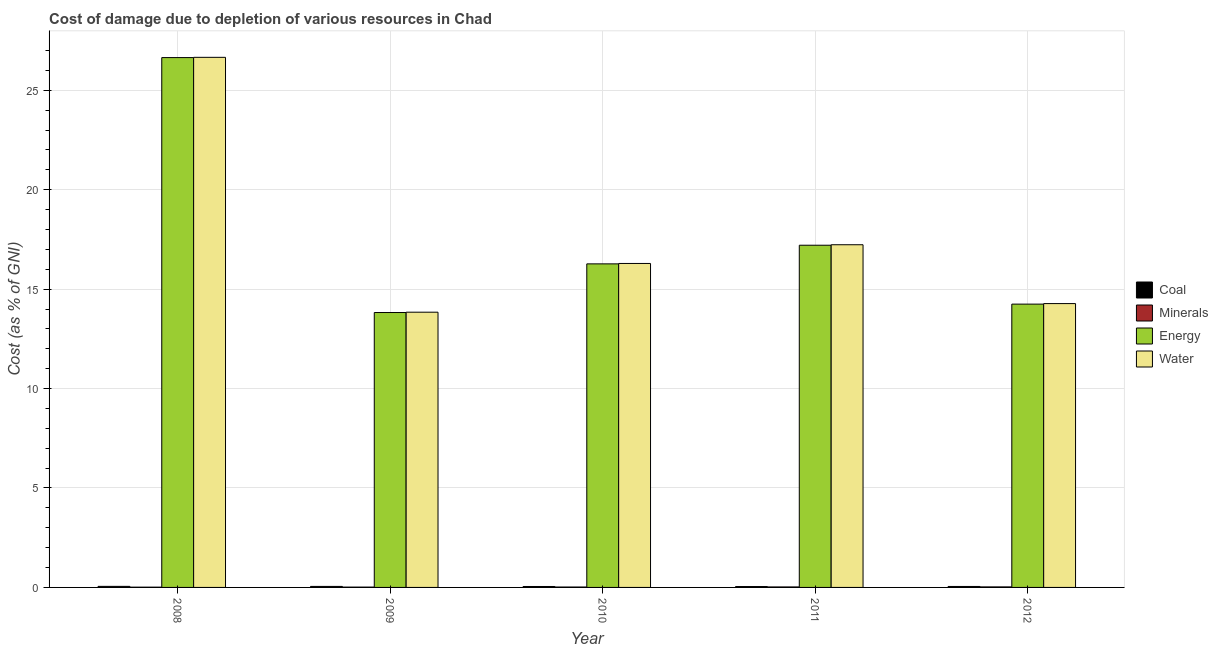How many groups of bars are there?
Keep it short and to the point. 5. Are the number of bars per tick equal to the number of legend labels?
Make the answer very short. Yes. Are the number of bars on each tick of the X-axis equal?
Your answer should be compact. Yes. What is the cost of damage due to depletion of minerals in 2008?
Provide a succinct answer. 0.01. Across all years, what is the maximum cost of damage due to depletion of minerals?
Your answer should be compact. 0.03. Across all years, what is the minimum cost of damage due to depletion of coal?
Your answer should be compact. 0.04. In which year was the cost of damage due to depletion of energy maximum?
Ensure brevity in your answer.  2008. In which year was the cost of damage due to depletion of water minimum?
Your answer should be very brief. 2009. What is the total cost of damage due to depletion of energy in the graph?
Your answer should be very brief. 88.19. What is the difference between the cost of damage due to depletion of minerals in 2008 and that in 2010?
Your answer should be very brief. -0.01. What is the difference between the cost of damage due to depletion of minerals in 2010 and the cost of damage due to depletion of coal in 2011?
Ensure brevity in your answer.  -0. What is the average cost of damage due to depletion of water per year?
Offer a terse response. 17.66. In the year 2008, what is the difference between the cost of damage due to depletion of coal and cost of damage due to depletion of energy?
Your response must be concise. 0. In how many years, is the cost of damage due to depletion of minerals greater than 15 %?
Offer a very short reply. 0. What is the ratio of the cost of damage due to depletion of coal in 2008 to that in 2009?
Provide a succinct answer. 1.04. Is the cost of damage due to depletion of coal in 2009 less than that in 2011?
Ensure brevity in your answer.  No. What is the difference between the highest and the second highest cost of damage due to depletion of minerals?
Your answer should be compact. 0. What is the difference between the highest and the lowest cost of damage due to depletion of minerals?
Provide a succinct answer. 0.01. What does the 3rd bar from the left in 2009 represents?
Ensure brevity in your answer.  Energy. What does the 3rd bar from the right in 2010 represents?
Provide a succinct answer. Minerals. How many bars are there?
Provide a succinct answer. 20. How many years are there in the graph?
Provide a succinct answer. 5. What is the difference between two consecutive major ticks on the Y-axis?
Your answer should be compact. 5. Does the graph contain grids?
Provide a short and direct response. Yes. What is the title of the graph?
Make the answer very short. Cost of damage due to depletion of various resources in Chad . What is the label or title of the X-axis?
Make the answer very short. Year. What is the label or title of the Y-axis?
Make the answer very short. Cost (as % of GNI). What is the Cost (as % of GNI) in Coal in 2008?
Provide a succinct answer. 0.05. What is the Cost (as % of GNI) in Minerals in 2008?
Ensure brevity in your answer.  0.01. What is the Cost (as % of GNI) of Energy in 2008?
Ensure brevity in your answer.  26.64. What is the Cost (as % of GNI) of Water in 2008?
Provide a short and direct response. 26.66. What is the Cost (as % of GNI) in Coal in 2009?
Provide a succinct answer. 0.05. What is the Cost (as % of GNI) of Minerals in 2009?
Provide a short and direct response. 0.02. What is the Cost (as % of GNI) of Energy in 2009?
Offer a very short reply. 13.82. What is the Cost (as % of GNI) of Water in 2009?
Your answer should be compact. 13.84. What is the Cost (as % of GNI) in Coal in 2010?
Ensure brevity in your answer.  0.05. What is the Cost (as % of GNI) of Minerals in 2010?
Your answer should be very brief. 0.02. What is the Cost (as % of GNI) in Energy in 2010?
Give a very brief answer. 16.27. What is the Cost (as % of GNI) in Water in 2010?
Give a very brief answer. 16.29. What is the Cost (as % of GNI) of Coal in 2011?
Make the answer very short. 0.04. What is the Cost (as % of GNI) of Minerals in 2011?
Keep it short and to the point. 0.02. What is the Cost (as % of GNI) of Energy in 2011?
Ensure brevity in your answer.  17.21. What is the Cost (as % of GNI) of Water in 2011?
Give a very brief answer. 17.23. What is the Cost (as % of GNI) of Coal in 2012?
Offer a very short reply. 0.05. What is the Cost (as % of GNI) of Minerals in 2012?
Offer a terse response. 0.03. What is the Cost (as % of GNI) in Energy in 2012?
Ensure brevity in your answer.  14.25. What is the Cost (as % of GNI) in Water in 2012?
Provide a short and direct response. 14.27. Across all years, what is the maximum Cost (as % of GNI) in Coal?
Your answer should be compact. 0.05. Across all years, what is the maximum Cost (as % of GNI) in Minerals?
Your answer should be very brief. 0.03. Across all years, what is the maximum Cost (as % of GNI) of Energy?
Your response must be concise. 26.64. Across all years, what is the maximum Cost (as % of GNI) of Water?
Make the answer very short. 26.66. Across all years, what is the minimum Cost (as % of GNI) in Coal?
Provide a short and direct response. 0.04. Across all years, what is the minimum Cost (as % of GNI) of Minerals?
Provide a succinct answer. 0.01. Across all years, what is the minimum Cost (as % of GNI) in Energy?
Make the answer very short. 13.82. Across all years, what is the minimum Cost (as % of GNI) in Water?
Your answer should be very brief. 13.84. What is the total Cost (as % of GNI) in Coal in the graph?
Offer a terse response. 0.24. What is the total Cost (as % of GNI) in Minerals in the graph?
Give a very brief answer. 0.1. What is the total Cost (as % of GNI) of Energy in the graph?
Provide a short and direct response. 88.19. What is the total Cost (as % of GNI) in Water in the graph?
Your answer should be very brief. 88.29. What is the difference between the Cost (as % of GNI) in Coal in 2008 and that in 2009?
Provide a short and direct response. 0. What is the difference between the Cost (as % of GNI) in Minerals in 2008 and that in 2009?
Offer a very short reply. -0. What is the difference between the Cost (as % of GNI) of Energy in 2008 and that in 2009?
Your response must be concise. 12.82. What is the difference between the Cost (as % of GNI) of Water in 2008 and that in 2009?
Ensure brevity in your answer.  12.82. What is the difference between the Cost (as % of GNI) in Coal in 2008 and that in 2010?
Provide a short and direct response. 0.01. What is the difference between the Cost (as % of GNI) of Minerals in 2008 and that in 2010?
Make the answer very short. -0.01. What is the difference between the Cost (as % of GNI) in Energy in 2008 and that in 2010?
Your answer should be compact. 10.37. What is the difference between the Cost (as % of GNI) in Water in 2008 and that in 2010?
Offer a terse response. 10.37. What is the difference between the Cost (as % of GNI) of Coal in 2008 and that in 2011?
Your answer should be compact. 0.01. What is the difference between the Cost (as % of GNI) in Minerals in 2008 and that in 2011?
Your answer should be compact. -0.01. What is the difference between the Cost (as % of GNI) in Energy in 2008 and that in 2011?
Ensure brevity in your answer.  9.44. What is the difference between the Cost (as % of GNI) in Water in 2008 and that in 2011?
Offer a very short reply. 9.42. What is the difference between the Cost (as % of GNI) in Coal in 2008 and that in 2012?
Provide a succinct answer. 0. What is the difference between the Cost (as % of GNI) in Minerals in 2008 and that in 2012?
Your answer should be very brief. -0.01. What is the difference between the Cost (as % of GNI) of Energy in 2008 and that in 2012?
Give a very brief answer. 12.4. What is the difference between the Cost (as % of GNI) of Water in 2008 and that in 2012?
Your response must be concise. 12.38. What is the difference between the Cost (as % of GNI) in Coal in 2009 and that in 2010?
Provide a short and direct response. 0. What is the difference between the Cost (as % of GNI) of Minerals in 2009 and that in 2010?
Make the answer very short. -0. What is the difference between the Cost (as % of GNI) in Energy in 2009 and that in 2010?
Make the answer very short. -2.45. What is the difference between the Cost (as % of GNI) in Water in 2009 and that in 2010?
Ensure brevity in your answer.  -2.45. What is the difference between the Cost (as % of GNI) of Coal in 2009 and that in 2011?
Your response must be concise. 0.01. What is the difference between the Cost (as % of GNI) of Minerals in 2009 and that in 2011?
Provide a short and direct response. -0.01. What is the difference between the Cost (as % of GNI) of Energy in 2009 and that in 2011?
Keep it short and to the point. -3.38. What is the difference between the Cost (as % of GNI) of Water in 2009 and that in 2011?
Your answer should be very brief. -3.39. What is the difference between the Cost (as % of GNI) in Coal in 2009 and that in 2012?
Offer a terse response. 0. What is the difference between the Cost (as % of GNI) of Minerals in 2009 and that in 2012?
Give a very brief answer. -0.01. What is the difference between the Cost (as % of GNI) in Energy in 2009 and that in 2012?
Make the answer very short. -0.42. What is the difference between the Cost (as % of GNI) in Water in 2009 and that in 2012?
Give a very brief answer. -0.43. What is the difference between the Cost (as % of GNI) in Coal in 2010 and that in 2011?
Make the answer very short. 0. What is the difference between the Cost (as % of GNI) of Minerals in 2010 and that in 2011?
Your answer should be compact. -0. What is the difference between the Cost (as % of GNI) in Energy in 2010 and that in 2011?
Provide a succinct answer. -0.94. What is the difference between the Cost (as % of GNI) in Water in 2010 and that in 2011?
Provide a succinct answer. -0.94. What is the difference between the Cost (as % of GNI) of Coal in 2010 and that in 2012?
Offer a terse response. -0. What is the difference between the Cost (as % of GNI) in Minerals in 2010 and that in 2012?
Give a very brief answer. -0.01. What is the difference between the Cost (as % of GNI) of Energy in 2010 and that in 2012?
Your response must be concise. 2.02. What is the difference between the Cost (as % of GNI) in Water in 2010 and that in 2012?
Offer a terse response. 2.02. What is the difference between the Cost (as % of GNI) in Coal in 2011 and that in 2012?
Offer a terse response. -0. What is the difference between the Cost (as % of GNI) of Minerals in 2011 and that in 2012?
Give a very brief answer. -0. What is the difference between the Cost (as % of GNI) of Energy in 2011 and that in 2012?
Make the answer very short. 2.96. What is the difference between the Cost (as % of GNI) in Water in 2011 and that in 2012?
Provide a short and direct response. 2.96. What is the difference between the Cost (as % of GNI) in Coal in 2008 and the Cost (as % of GNI) in Minerals in 2009?
Offer a very short reply. 0.04. What is the difference between the Cost (as % of GNI) of Coal in 2008 and the Cost (as % of GNI) of Energy in 2009?
Keep it short and to the point. -13.77. What is the difference between the Cost (as % of GNI) in Coal in 2008 and the Cost (as % of GNI) in Water in 2009?
Your answer should be very brief. -13.79. What is the difference between the Cost (as % of GNI) of Minerals in 2008 and the Cost (as % of GNI) of Energy in 2009?
Give a very brief answer. -13.81. What is the difference between the Cost (as % of GNI) in Minerals in 2008 and the Cost (as % of GNI) in Water in 2009?
Offer a terse response. -13.83. What is the difference between the Cost (as % of GNI) of Energy in 2008 and the Cost (as % of GNI) of Water in 2009?
Your response must be concise. 12.8. What is the difference between the Cost (as % of GNI) in Coal in 2008 and the Cost (as % of GNI) in Minerals in 2010?
Provide a succinct answer. 0.03. What is the difference between the Cost (as % of GNI) in Coal in 2008 and the Cost (as % of GNI) in Energy in 2010?
Your response must be concise. -16.22. What is the difference between the Cost (as % of GNI) of Coal in 2008 and the Cost (as % of GNI) of Water in 2010?
Make the answer very short. -16.24. What is the difference between the Cost (as % of GNI) in Minerals in 2008 and the Cost (as % of GNI) in Energy in 2010?
Offer a very short reply. -16.26. What is the difference between the Cost (as % of GNI) of Minerals in 2008 and the Cost (as % of GNI) of Water in 2010?
Provide a succinct answer. -16.28. What is the difference between the Cost (as % of GNI) in Energy in 2008 and the Cost (as % of GNI) in Water in 2010?
Provide a succinct answer. 10.35. What is the difference between the Cost (as % of GNI) of Coal in 2008 and the Cost (as % of GNI) of Minerals in 2011?
Ensure brevity in your answer.  0.03. What is the difference between the Cost (as % of GNI) of Coal in 2008 and the Cost (as % of GNI) of Energy in 2011?
Your answer should be compact. -17.15. What is the difference between the Cost (as % of GNI) in Coal in 2008 and the Cost (as % of GNI) in Water in 2011?
Provide a short and direct response. -17.18. What is the difference between the Cost (as % of GNI) in Minerals in 2008 and the Cost (as % of GNI) in Energy in 2011?
Your response must be concise. -17.19. What is the difference between the Cost (as % of GNI) in Minerals in 2008 and the Cost (as % of GNI) in Water in 2011?
Keep it short and to the point. -17.22. What is the difference between the Cost (as % of GNI) of Energy in 2008 and the Cost (as % of GNI) of Water in 2011?
Make the answer very short. 9.41. What is the difference between the Cost (as % of GNI) of Coal in 2008 and the Cost (as % of GNI) of Minerals in 2012?
Offer a terse response. 0.03. What is the difference between the Cost (as % of GNI) of Coal in 2008 and the Cost (as % of GNI) of Energy in 2012?
Give a very brief answer. -14.19. What is the difference between the Cost (as % of GNI) in Coal in 2008 and the Cost (as % of GNI) in Water in 2012?
Offer a terse response. -14.22. What is the difference between the Cost (as % of GNI) in Minerals in 2008 and the Cost (as % of GNI) in Energy in 2012?
Provide a short and direct response. -14.23. What is the difference between the Cost (as % of GNI) in Minerals in 2008 and the Cost (as % of GNI) in Water in 2012?
Provide a succinct answer. -14.26. What is the difference between the Cost (as % of GNI) in Energy in 2008 and the Cost (as % of GNI) in Water in 2012?
Your response must be concise. 12.37. What is the difference between the Cost (as % of GNI) in Coal in 2009 and the Cost (as % of GNI) in Minerals in 2010?
Your answer should be very brief. 0.03. What is the difference between the Cost (as % of GNI) in Coal in 2009 and the Cost (as % of GNI) in Energy in 2010?
Ensure brevity in your answer.  -16.22. What is the difference between the Cost (as % of GNI) of Coal in 2009 and the Cost (as % of GNI) of Water in 2010?
Ensure brevity in your answer.  -16.24. What is the difference between the Cost (as % of GNI) of Minerals in 2009 and the Cost (as % of GNI) of Energy in 2010?
Give a very brief answer. -16.25. What is the difference between the Cost (as % of GNI) in Minerals in 2009 and the Cost (as % of GNI) in Water in 2010?
Provide a short and direct response. -16.27. What is the difference between the Cost (as % of GNI) of Energy in 2009 and the Cost (as % of GNI) of Water in 2010?
Provide a short and direct response. -2.47. What is the difference between the Cost (as % of GNI) of Coal in 2009 and the Cost (as % of GNI) of Minerals in 2011?
Make the answer very short. 0.03. What is the difference between the Cost (as % of GNI) of Coal in 2009 and the Cost (as % of GNI) of Energy in 2011?
Your answer should be compact. -17.16. What is the difference between the Cost (as % of GNI) in Coal in 2009 and the Cost (as % of GNI) in Water in 2011?
Offer a very short reply. -17.18. What is the difference between the Cost (as % of GNI) of Minerals in 2009 and the Cost (as % of GNI) of Energy in 2011?
Provide a succinct answer. -17.19. What is the difference between the Cost (as % of GNI) of Minerals in 2009 and the Cost (as % of GNI) of Water in 2011?
Your answer should be very brief. -17.22. What is the difference between the Cost (as % of GNI) of Energy in 2009 and the Cost (as % of GNI) of Water in 2011?
Make the answer very short. -3.41. What is the difference between the Cost (as % of GNI) of Coal in 2009 and the Cost (as % of GNI) of Minerals in 2012?
Your answer should be compact. 0.02. What is the difference between the Cost (as % of GNI) of Coal in 2009 and the Cost (as % of GNI) of Energy in 2012?
Keep it short and to the point. -14.2. What is the difference between the Cost (as % of GNI) of Coal in 2009 and the Cost (as % of GNI) of Water in 2012?
Give a very brief answer. -14.22. What is the difference between the Cost (as % of GNI) of Minerals in 2009 and the Cost (as % of GNI) of Energy in 2012?
Give a very brief answer. -14.23. What is the difference between the Cost (as % of GNI) of Minerals in 2009 and the Cost (as % of GNI) of Water in 2012?
Provide a short and direct response. -14.26. What is the difference between the Cost (as % of GNI) in Energy in 2009 and the Cost (as % of GNI) in Water in 2012?
Make the answer very short. -0.45. What is the difference between the Cost (as % of GNI) in Coal in 2010 and the Cost (as % of GNI) in Minerals in 2011?
Ensure brevity in your answer.  0.02. What is the difference between the Cost (as % of GNI) in Coal in 2010 and the Cost (as % of GNI) in Energy in 2011?
Your answer should be compact. -17.16. What is the difference between the Cost (as % of GNI) in Coal in 2010 and the Cost (as % of GNI) in Water in 2011?
Your answer should be very brief. -17.18. What is the difference between the Cost (as % of GNI) in Minerals in 2010 and the Cost (as % of GNI) in Energy in 2011?
Ensure brevity in your answer.  -17.19. What is the difference between the Cost (as % of GNI) of Minerals in 2010 and the Cost (as % of GNI) of Water in 2011?
Provide a short and direct response. -17.21. What is the difference between the Cost (as % of GNI) of Energy in 2010 and the Cost (as % of GNI) of Water in 2011?
Offer a very short reply. -0.96. What is the difference between the Cost (as % of GNI) of Coal in 2010 and the Cost (as % of GNI) of Minerals in 2012?
Keep it short and to the point. 0.02. What is the difference between the Cost (as % of GNI) of Coal in 2010 and the Cost (as % of GNI) of Energy in 2012?
Give a very brief answer. -14.2. What is the difference between the Cost (as % of GNI) in Coal in 2010 and the Cost (as % of GNI) in Water in 2012?
Offer a terse response. -14.23. What is the difference between the Cost (as % of GNI) in Minerals in 2010 and the Cost (as % of GNI) in Energy in 2012?
Provide a succinct answer. -14.23. What is the difference between the Cost (as % of GNI) in Minerals in 2010 and the Cost (as % of GNI) in Water in 2012?
Your response must be concise. -14.25. What is the difference between the Cost (as % of GNI) in Energy in 2010 and the Cost (as % of GNI) in Water in 2012?
Keep it short and to the point. 2. What is the difference between the Cost (as % of GNI) in Coal in 2011 and the Cost (as % of GNI) in Minerals in 2012?
Your response must be concise. 0.02. What is the difference between the Cost (as % of GNI) of Coal in 2011 and the Cost (as % of GNI) of Energy in 2012?
Your answer should be very brief. -14.2. What is the difference between the Cost (as % of GNI) in Coal in 2011 and the Cost (as % of GNI) in Water in 2012?
Provide a short and direct response. -14.23. What is the difference between the Cost (as % of GNI) in Minerals in 2011 and the Cost (as % of GNI) in Energy in 2012?
Offer a very short reply. -14.22. What is the difference between the Cost (as % of GNI) in Minerals in 2011 and the Cost (as % of GNI) in Water in 2012?
Keep it short and to the point. -14.25. What is the difference between the Cost (as % of GNI) of Energy in 2011 and the Cost (as % of GNI) of Water in 2012?
Offer a terse response. 2.93. What is the average Cost (as % of GNI) in Coal per year?
Your answer should be very brief. 0.05. What is the average Cost (as % of GNI) in Minerals per year?
Offer a terse response. 0.02. What is the average Cost (as % of GNI) in Energy per year?
Your response must be concise. 17.64. What is the average Cost (as % of GNI) of Water per year?
Offer a very short reply. 17.66. In the year 2008, what is the difference between the Cost (as % of GNI) in Coal and Cost (as % of GNI) in Minerals?
Keep it short and to the point. 0.04. In the year 2008, what is the difference between the Cost (as % of GNI) of Coal and Cost (as % of GNI) of Energy?
Make the answer very short. -26.59. In the year 2008, what is the difference between the Cost (as % of GNI) in Coal and Cost (as % of GNI) in Water?
Ensure brevity in your answer.  -26.6. In the year 2008, what is the difference between the Cost (as % of GNI) of Minerals and Cost (as % of GNI) of Energy?
Provide a succinct answer. -26.63. In the year 2008, what is the difference between the Cost (as % of GNI) of Minerals and Cost (as % of GNI) of Water?
Offer a very short reply. -26.64. In the year 2008, what is the difference between the Cost (as % of GNI) in Energy and Cost (as % of GNI) in Water?
Provide a succinct answer. -0.01. In the year 2009, what is the difference between the Cost (as % of GNI) in Coal and Cost (as % of GNI) in Minerals?
Keep it short and to the point. 0.03. In the year 2009, what is the difference between the Cost (as % of GNI) of Coal and Cost (as % of GNI) of Energy?
Provide a succinct answer. -13.77. In the year 2009, what is the difference between the Cost (as % of GNI) in Coal and Cost (as % of GNI) in Water?
Provide a short and direct response. -13.79. In the year 2009, what is the difference between the Cost (as % of GNI) of Minerals and Cost (as % of GNI) of Energy?
Your answer should be compact. -13.81. In the year 2009, what is the difference between the Cost (as % of GNI) of Minerals and Cost (as % of GNI) of Water?
Keep it short and to the point. -13.82. In the year 2009, what is the difference between the Cost (as % of GNI) of Energy and Cost (as % of GNI) of Water?
Provide a succinct answer. -0.02. In the year 2010, what is the difference between the Cost (as % of GNI) in Coal and Cost (as % of GNI) in Minerals?
Your answer should be compact. 0.03. In the year 2010, what is the difference between the Cost (as % of GNI) of Coal and Cost (as % of GNI) of Energy?
Your answer should be compact. -16.22. In the year 2010, what is the difference between the Cost (as % of GNI) in Coal and Cost (as % of GNI) in Water?
Provide a succinct answer. -16.24. In the year 2010, what is the difference between the Cost (as % of GNI) in Minerals and Cost (as % of GNI) in Energy?
Offer a very short reply. -16.25. In the year 2010, what is the difference between the Cost (as % of GNI) of Minerals and Cost (as % of GNI) of Water?
Give a very brief answer. -16.27. In the year 2010, what is the difference between the Cost (as % of GNI) in Energy and Cost (as % of GNI) in Water?
Your answer should be very brief. -0.02. In the year 2011, what is the difference between the Cost (as % of GNI) of Coal and Cost (as % of GNI) of Minerals?
Provide a succinct answer. 0.02. In the year 2011, what is the difference between the Cost (as % of GNI) of Coal and Cost (as % of GNI) of Energy?
Offer a very short reply. -17.16. In the year 2011, what is the difference between the Cost (as % of GNI) in Coal and Cost (as % of GNI) in Water?
Give a very brief answer. -17.19. In the year 2011, what is the difference between the Cost (as % of GNI) in Minerals and Cost (as % of GNI) in Energy?
Provide a succinct answer. -17.18. In the year 2011, what is the difference between the Cost (as % of GNI) of Minerals and Cost (as % of GNI) of Water?
Keep it short and to the point. -17.21. In the year 2011, what is the difference between the Cost (as % of GNI) of Energy and Cost (as % of GNI) of Water?
Provide a short and direct response. -0.02. In the year 2012, what is the difference between the Cost (as % of GNI) of Coal and Cost (as % of GNI) of Minerals?
Give a very brief answer. 0.02. In the year 2012, what is the difference between the Cost (as % of GNI) in Coal and Cost (as % of GNI) in Energy?
Provide a succinct answer. -14.2. In the year 2012, what is the difference between the Cost (as % of GNI) of Coal and Cost (as % of GNI) of Water?
Keep it short and to the point. -14.22. In the year 2012, what is the difference between the Cost (as % of GNI) of Minerals and Cost (as % of GNI) of Energy?
Make the answer very short. -14.22. In the year 2012, what is the difference between the Cost (as % of GNI) in Minerals and Cost (as % of GNI) in Water?
Offer a very short reply. -14.25. In the year 2012, what is the difference between the Cost (as % of GNI) of Energy and Cost (as % of GNI) of Water?
Keep it short and to the point. -0.03. What is the ratio of the Cost (as % of GNI) in Coal in 2008 to that in 2009?
Your response must be concise. 1.04. What is the ratio of the Cost (as % of GNI) of Minerals in 2008 to that in 2009?
Offer a terse response. 0.8. What is the ratio of the Cost (as % of GNI) of Energy in 2008 to that in 2009?
Make the answer very short. 1.93. What is the ratio of the Cost (as % of GNI) of Water in 2008 to that in 2009?
Offer a very short reply. 1.93. What is the ratio of the Cost (as % of GNI) in Coal in 2008 to that in 2010?
Your answer should be compact. 1.12. What is the ratio of the Cost (as % of GNI) of Minerals in 2008 to that in 2010?
Make the answer very short. 0.64. What is the ratio of the Cost (as % of GNI) in Energy in 2008 to that in 2010?
Your answer should be compact. 1.64. What is the ratio of the Cost (as % of GNI) of Water in 2008 to that in 2010?
Offer a very short reply. 1.64. What is the ratio of the Cost (as % of GNI) of Coal in 2008 to that in 2011?
Your response must be concise. 1.2. What is the ratio of the Cost (as % of GNI) of Minerals in 2008 to that in 2011?
Your answer should be very brief. 0.52. What is the ratio of the Cost (as % of GNI) in Energy in 2008 to that in 2011?
Your answer should be very brief. 1.55. What is the ratio of the Cost (as % of GNI) in Water in 2008 to that in 2011?
Keep it short and to the point. 1.55. What is the ratio of the Cost (as % of GNI) of Coal in 2008 to that in 2012?
Offer a very short reply. 1.09. What is the ratio of the Cost (as % of GNI) in Minerals in 2008 to that in 2012?
Offer a very short reply. 0.49. What is the ratio of the Cost (as % of GNI) of Energy in 2008 to that in 2012?
Your answer should be very brief. 1.87. What is the ratio of the Cost (as % of GNI) in Water in 2008 to that in 2012?
Provide a succinct answer. 1.87. What is the ratio of the Cost (as % of GNI) of Coal in 2009 to that in 2010?
Your answer should be very brief. 1.08. What is the ratio of the Cost (as % of GNI) of Minerals in 2009 to that in 2010?
Ensure brevity in your answer.  0.8. What is the ratio of the Cost (as % of GNI) of Energy in 2009 to that in 2010?
Your response must be concise. 0.85. What is the ratio of the Cost (as % of GNI) of Water in 2009 to that in 2010?
Provide a short and direct response. 0.85. What is the ratio of the Cost (as % of GNI) in Coal in 2009 to that in 2011?
Your answer should be very brief. 1.15. What is the ratio of the Cost (as % of GNI) in Minerals in 2009 to that in 2011?
Provide a succinct answer. 0.66. What is the ratio of the Cost (as % of GNI) of Energy in 2009 to that in 2011?
Ensure brevity in your answer.  0.8. What is the ratio of the Cost (as % of GNI) of Water in 2009 to that in 2011?
Keep it short and to the point. 0.8. What is the ratio of the Cost (as % of GNI) in Coal in 2009 to that in 2012?
Provide a succinct answer. 1.05. What is the ratio of the Cost (as % of GNI) of Minerals in 2009 to that in 2012?
Keep it short and to the point. 0.61. What is the ratio of the Cost (as % of GNI) in Energy in 2009 to that in 2012?
Keep it short and to the point. 0.97. What is the ratio of the Cost (as % of GNI) in Water in 2009 to that in 2012?
Your answer should be very brief. 0.97. What is the ratio of the Cost (as % of GNI) of Coal in 2010 to that in 2011?
Keep it short and to the point. 1.07. What is the ratio of the Cost (as % of GNI) of Minerals in 2010 to that in 2011?
Give a very brief answer. 0.82. What is the ratio of the Cost (as % of GNI) in Energy in 2010 to that in 2011?
Offer a terse response. 0.95. What is the ratio of the Cost (as % of GNI) in Water in 2010 to that in 2011?
Your answer should be compact. 0.95. What is the ratio of the Cost (as % of GNI) of Coal in 2010 to that in 2012?
Your response must be concise. 0.97. What is the ratio of the Cost (as % of GNI) in Minerals in 2010 to that in 2012?
Your answer should be compact. 0.77. What is the ratio of the Cost (as % of GNI) in Energy in 2010 to that in 2012?
Keep it short and to the point. 1.14. What is the ratio of the Cost (as % of GNI) in Water in 2010 to that in 2012?
Ensure brevity in your answer.  1.14. What is the ratio of the Cost (as % of GNI) in Coal in 2011 to that in 2012?
Give a very brief answer. 0.91. What is the ratio of the Cost (as % of GNI) in Minerals in 2011 to that in 2012?
Provide a succinct answer. 0.94. What is the ratio of the Cost (as % of GNI) in Energy in 2011 to that in 2012?
Make the answer very short. 1.21. What is the ratio of the Cost (as % of GNI) in Water in 2011 to that in 2012?
Offer a very short reply. 1.21. What is the difference between the highest and the second highest Cost (as % of GNI) of Coal?
Give a very brief answer. 0. What is the difference between the highest and the second highest Cost (as % of GNI) in Minerals?
Ensure brevity in your answer.  0. What is the difference between the highest and the second highest Cost (as % of GNI) in Energy?
Your response must be concise. 9.44. What is the difference between the highest and the second highest Cost (as % of GNI) of Water?
Your response must be concise. 9.42. What is the difference between the highest and the lowest Cost (as % of GNI) of Coal?
Provide a short and direct response. 0.01. What is the difference between the highest and the lowest Cost (as % of GNI) in Minerals?
Your answer should be compact. 0.01. What is the difference between the highest and the lowest Cost (as % of GNI) in Energy?
Give a very brief answer. 12.82. What is the difference between the highest and the lowest Cost (as % of GNI) in Water?
Provide a succinct answer. 12.82. 